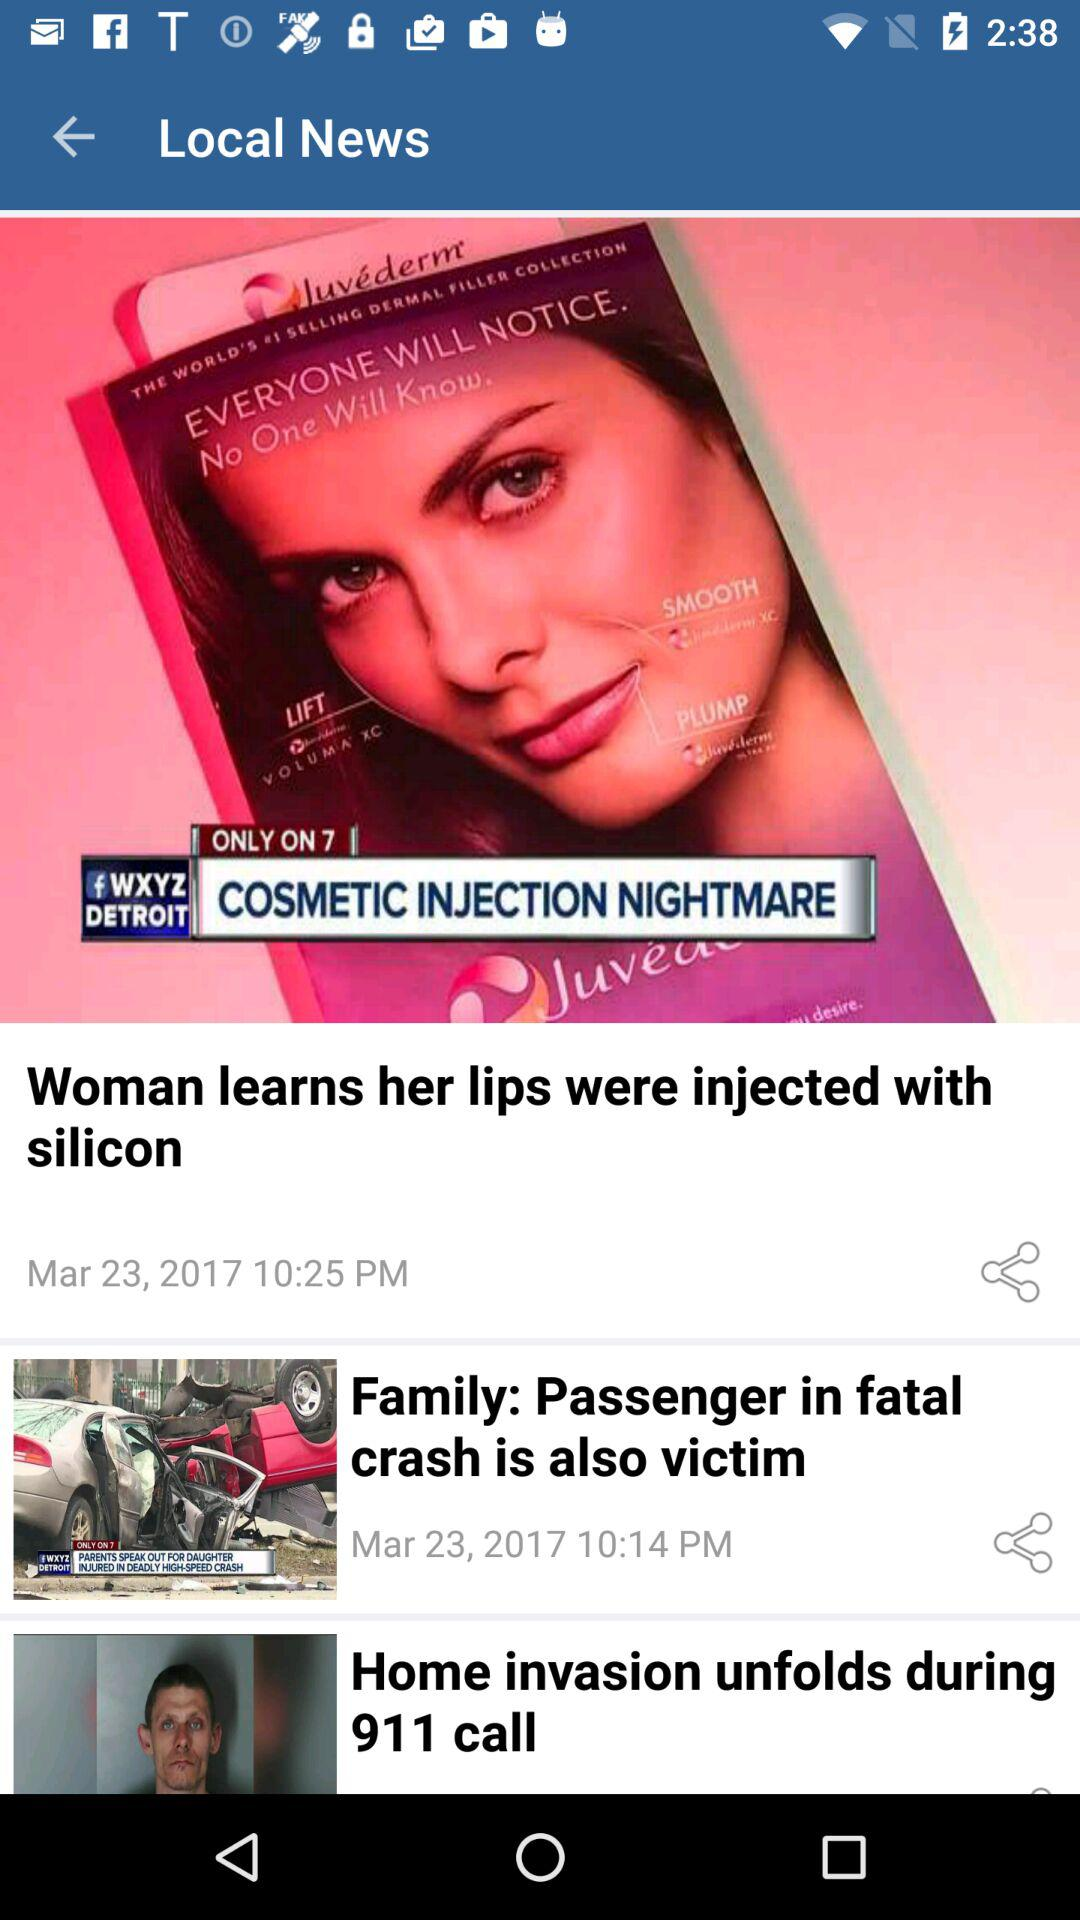What is the posted time of the news "Family: Passenger in fatal crash is also victim"? The posted time is 10:14 PM. 